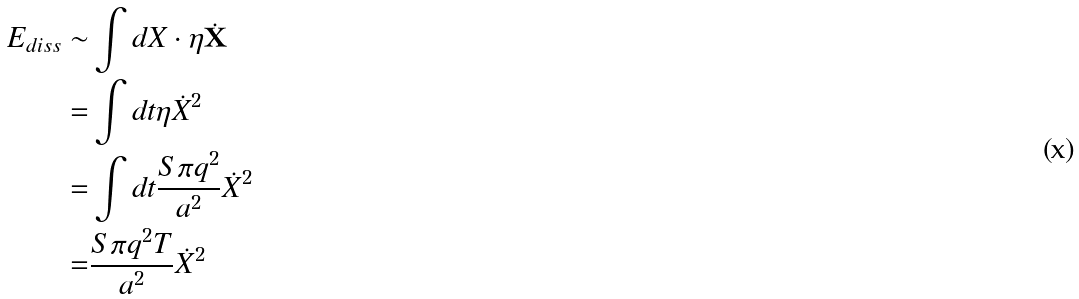Convert formula to latex. <formula><loc_0><loc_0><loc_500><loc_500>E _ { d i s s } \sim & \int d X \cdot \eta \dot { \mathbf X } \\ = & \int d t \eta \dot { X } ^ { 2 } \\ = & \int d t \frac { S \pi q ^ { 2 } } { a ^ { 2 } } \dot { X } ^ { 2 } \\ = & \frac { S \pi q ^ { 2 } T } { a ^ { 2 } } \dot { X } ^ { 2 }</formula> 